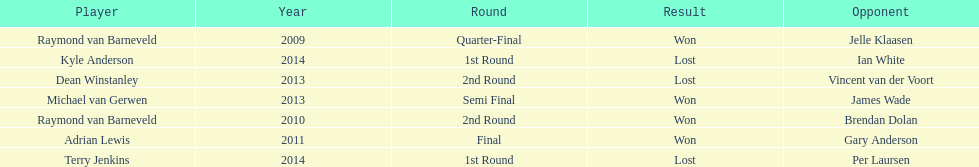Who are the only players listed that played in 2011? Adrian Lewis. 